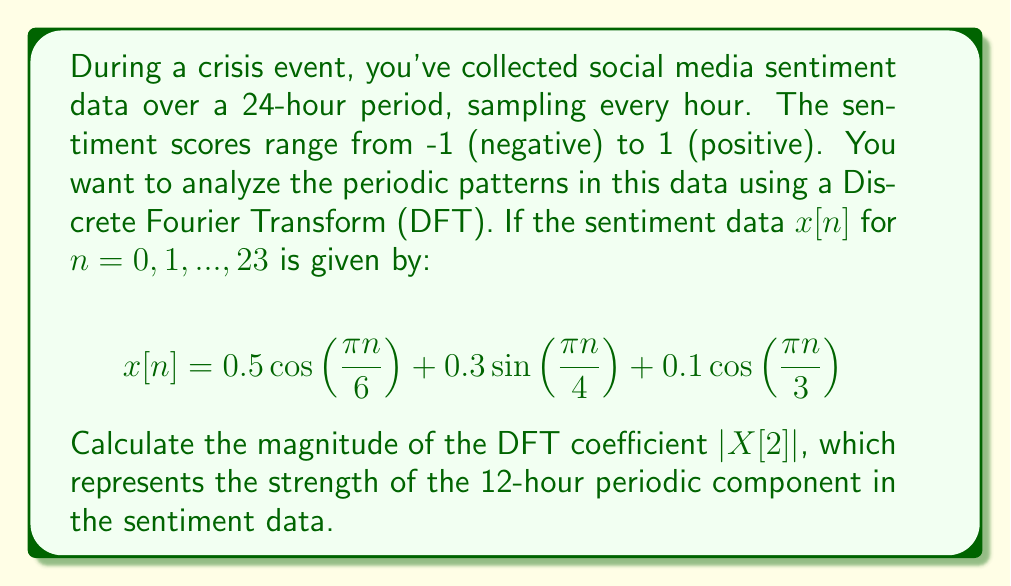Help me with this question. To solve this problem, we'll follow these steps:

1) The Discrete Fourier Transform (DFT) of a sequence $x[n]$ is given by:

   $X[k] = \sum_{n=0}^{N-1} x[n] e^{-j2\pi kn/N}$

   where $N$ is the number of samples (24 in this case).

2) We need to calculate $X[2]$, which corresponds to the 12-hour periodic component:

   $X[2] = \sum_{n=0}^{23} x[n] e^{-j2\pi 2n/24} = \sum_{n=0}^{23} x[n] e^{-j\pi n/6}$

3) Substitute the given $x[n]$ into this equation:

   $X[2] = \sum_{n=0}^{23} [0.5 \cos(\frac{\pi n}{6}) + 0.3 \sin(\frac{\pi n}{4}) + 0.1 \cos(\frac{\pi n}{3})] e^{-j\pi n/6}$

4) We can separate this into three sums:

   $X[2] = 0.5 \sum_{n=0}^{23} \cos(\frac{\pi n}{6}) e^{-j\pi n/6} + 0.3 \sum_{n=0}^{23} \sin(\frac{\pi n}{4}) e^{-j\pi n/6} + 0.1 \sum_{n=0}^{23} \cos(\frac{\pi n}{3}) e^{-j\pi n/6}$

5) The first sum is the only one that will have a significant non-zero value, as it matches the frequency of $e^{-j\pi n/6}$. The other two sums will be close to zero due to orthogonality.

6) For the first sum:

   $\cos(\frac{\pi n}{6}) e^{-j\pi n/6} = \frac{1}{2}(e^{j\pi n/6} + e^{-j\pi n/6}) e^{-j\pi n/6} = \frac{1}{2}(1 + e^{-j\pi n/3})$

7) Summing this over 24 terms:

   $\sum_{n=0}^{23} \cos(\frac{\pi n}{6}) e^{-j\pi n/6} = \frac{1}{2}(24 + 0) = 12$

8) Therefore, $X[2] \approx 0.5 \cdot 12 = 6$

9) The magnitude of $X[2]$ is thus $|X[2]| = 6$
Answer: $|X[2]| = 6$ 